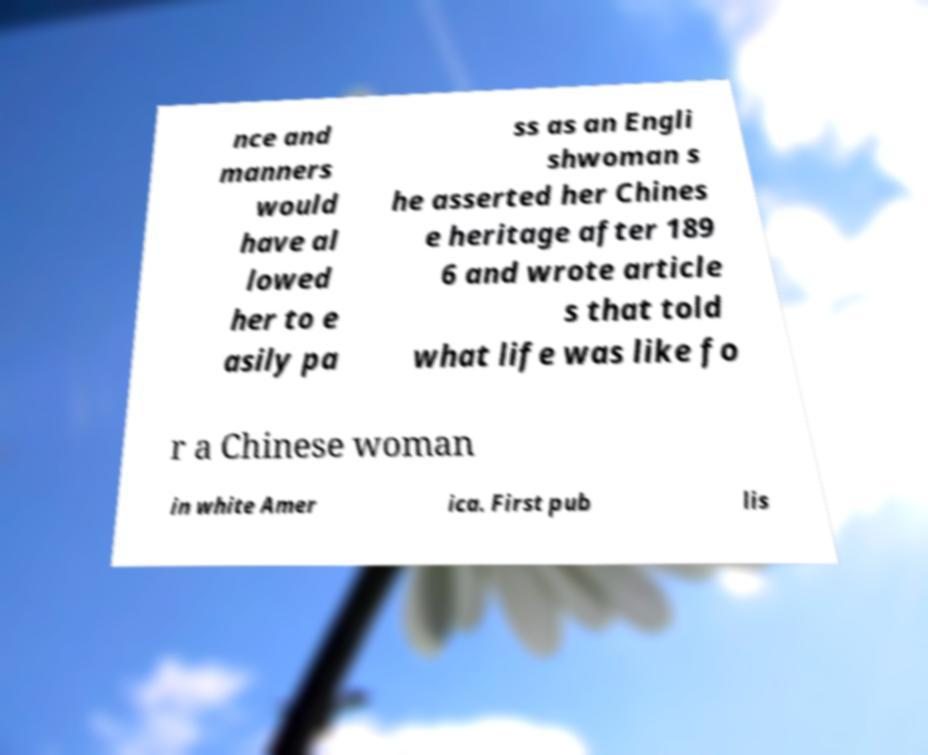There's text embedded in this image that I need extracted. Can you transcribe it verbatim? nce and manners would have al lowed her to e asily pa ss as an Engli shwoman s he asserted her Chines e heritage after 189 6 and wrote article s that told what life was like fo r a Chinese woman in white Amer ica. First pub lis 